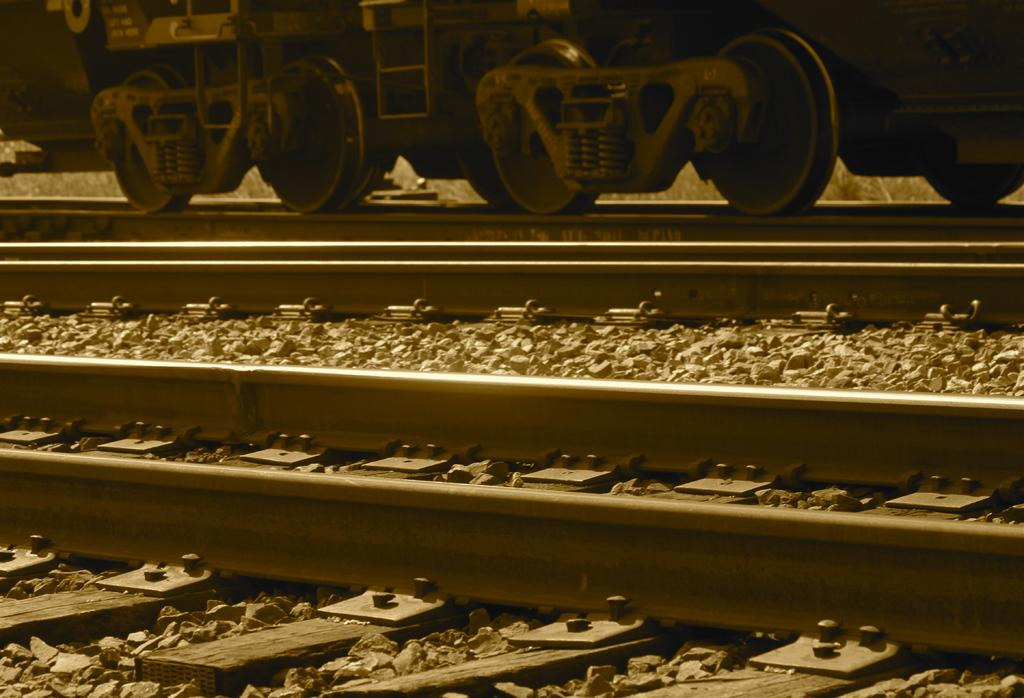What is the main subject of the image? The main subject of the image is a train. What feature of the train is mentioned in the facts? The train has wheels. What is located at the bottom of the image? There are tracks at the bottom of the image. What can be seen alongside the tracks? Stones are present along the tracks. Can you tell me how many drains are visible near the train in the image? There are no drains visible near the train in the image. What type of show is being performed by the train in the image? The train is not performing a show in the image; it is simply depicted on the tracks. 